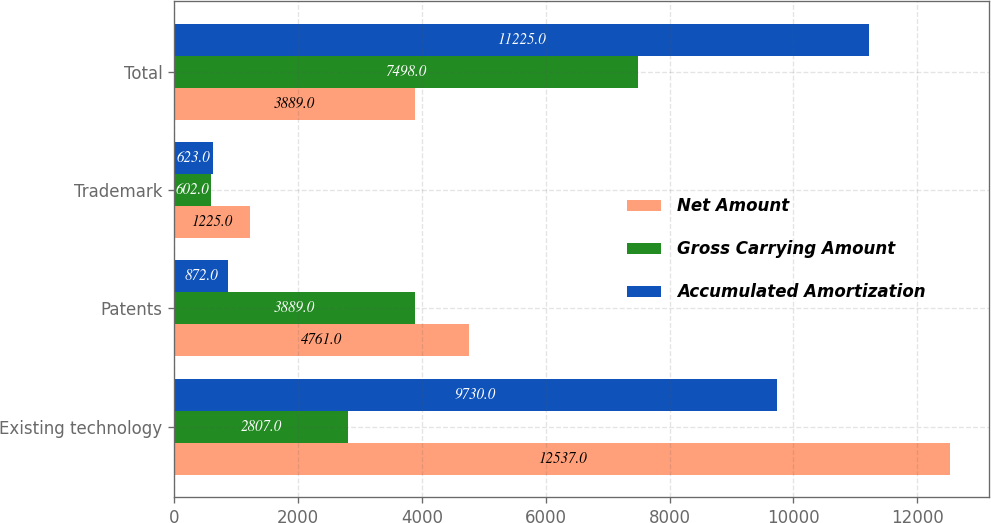Convert chart. <chart><loc_0><loc_0><loc_500><loc_500><stacked_bar_chart><ecel><fcel>Existing technology<fcel>Patents<fcel>Trademark<fcel>Total<nl><fcel>Net Amount<fcel>12537<fcel>4761<fcel>1225<fcel>3889<nl><fcel>Gross Carrying Amount<fcel>2807<fcel>3889<fcel>602<fcel>7498<nl><fcel>Accumulated Amortization<fcel>9730<fcel>872<fcel>623<fcel>11225<nl></chart> 